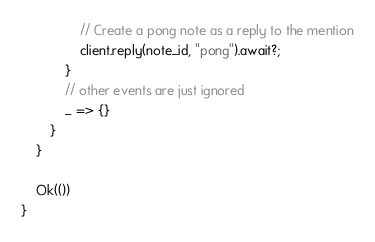Convert code to text. <code><loc_0><loc_0><loc_500><loc_500><_Rust_>
                // Create a pong note as a reply to the mention
                client.reply(note_id, "pong").await?;
            }
            // other events are just ignored
            _ => {}
        }
    }

    Ok(())
}
</code> 